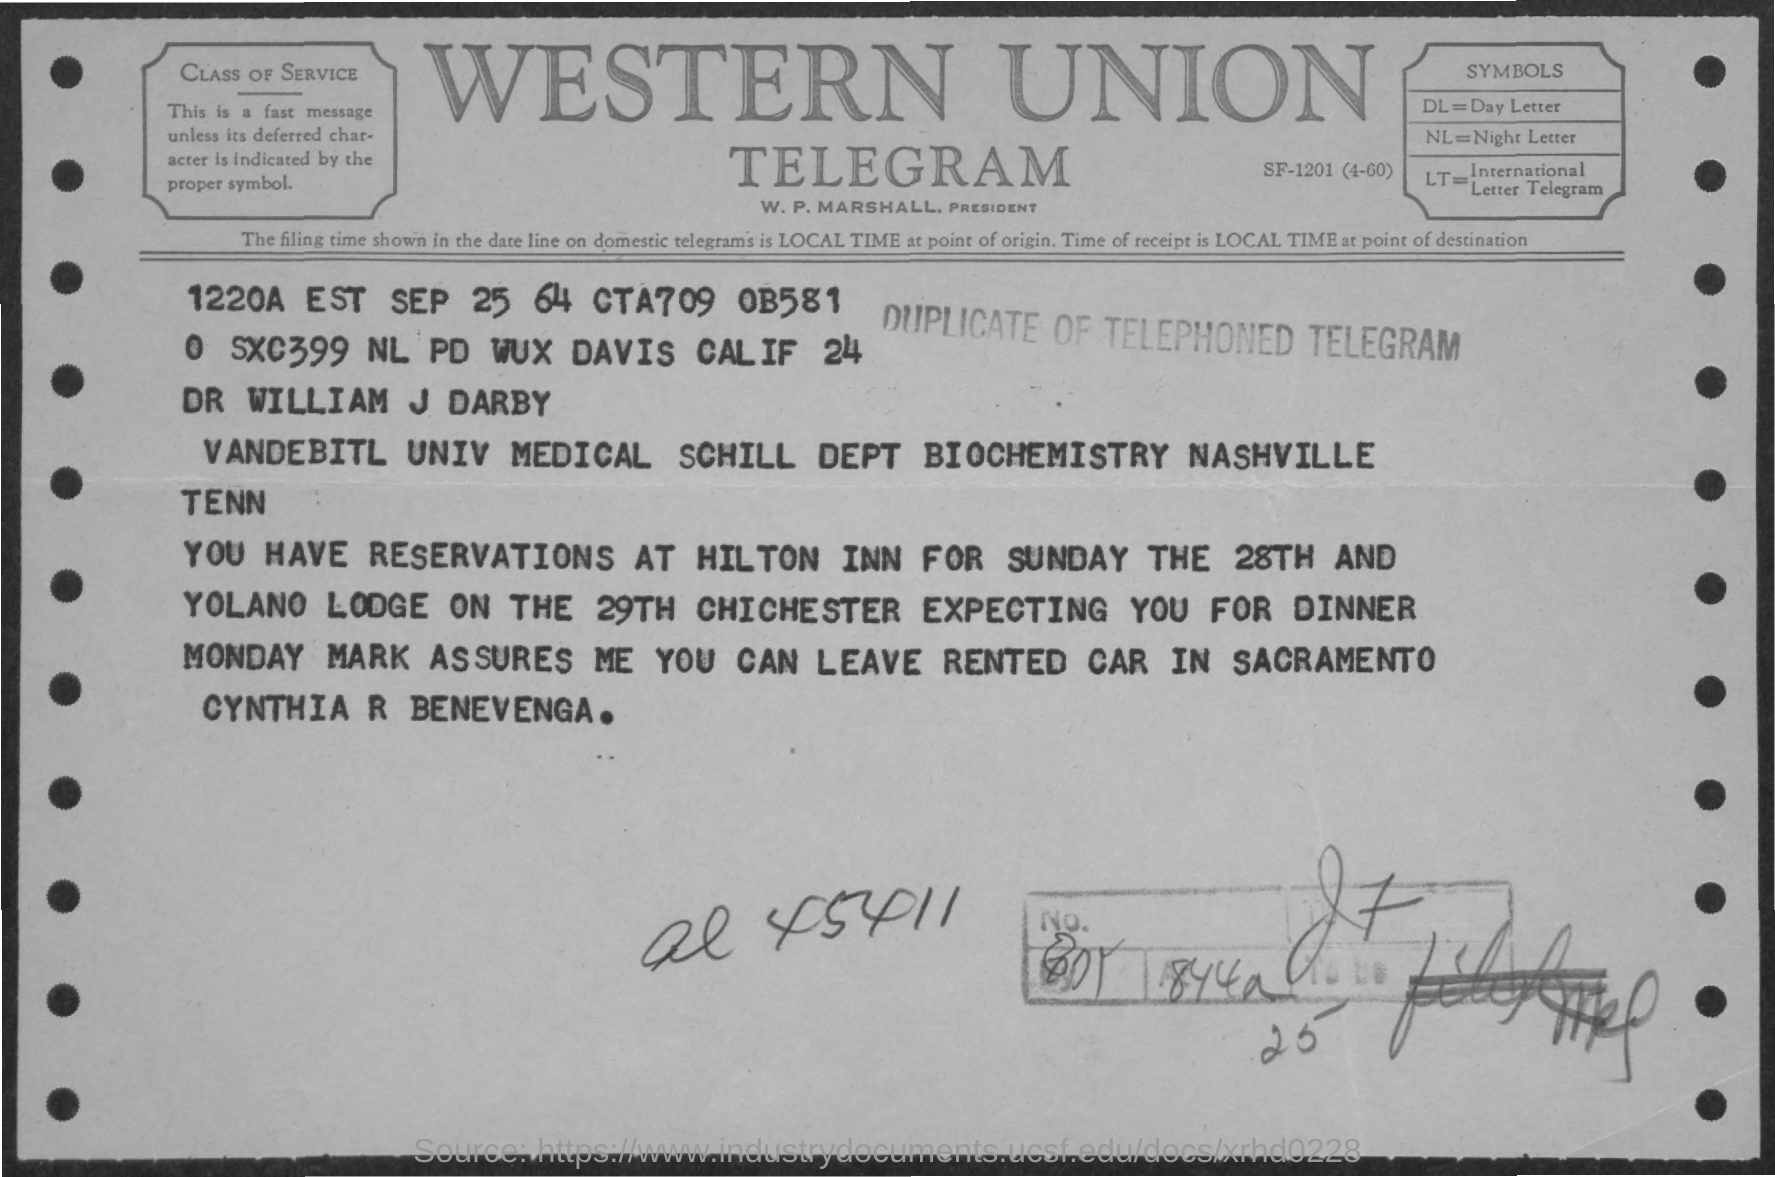What is the name mentioned?
Give a very brief answer. DR WILLIAM J DARBY. 